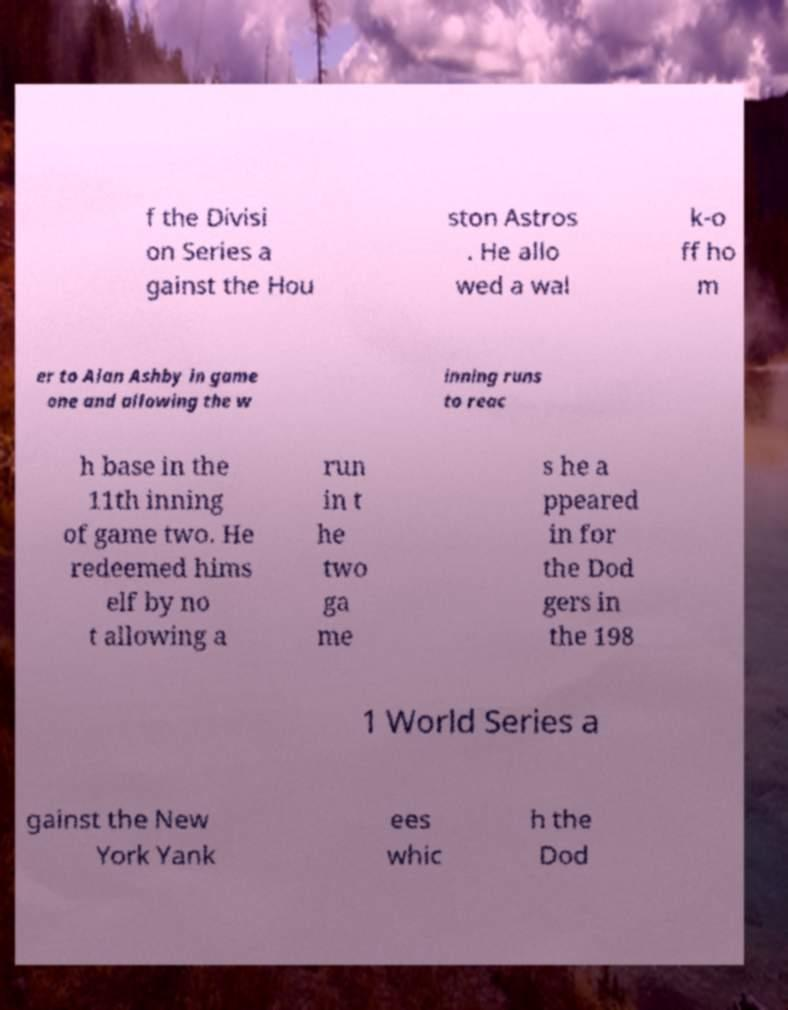What messages or text are displayed in this image? I need them in a readable, typed format. f the Divisi on Series a gainst the Hou ston Astros . He allo wed a wal k-o ff ho m er to Alan Ashby in game one and allowing the w inning runs to reac h base in the 11th inning of game two. He redeemed hims elf by no t allowing a run in t he two ga me s he a ppeared in for the Dod gers in the 198 1 World Series a gainst the New York Yank ees whic h the Dod 